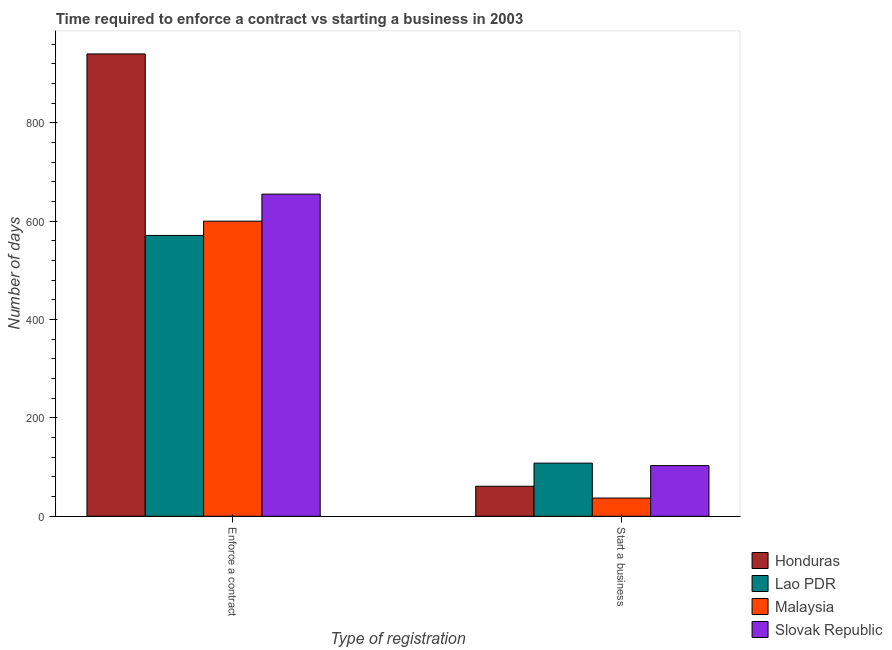How many different coloured bars are there?
Provide a short and direct response. 4. Are the number of bars per tick equal to the number of legend labels?
Keep it short and to the point. Yes. How many bars are there on the 2nd tick from the left?
Make the answer very short. 4. What is the label of the 1st group of bars from the left?
Give a very brief answer. Enforce a contract. What is the number of days to start a business in Honduras?
Give a very brief answer. 61. Across all countries, what is the maximum number of days to enforece a contract?
Your response must be concise. 940. Across all countries, what is the minimum number of days to enforece a contract?
Give a very brief answer. 571. In which country was the number of days to enforece a contract maximum?
Give a very brief answer. Honduras. In which country was the number of days to start a business minimum?
Your answer should be very brief. Malaysia. What is the total number of days to start a business in the graph?
Keep it short and to the point. 309. What is the difference between the number of days to enforece a contract in Honduras and that in Lao PDR?
Your response must be concise. 369. What is the difference between the number of days to start a business in Lao PDR and the number of days to enforece a contract in Honduras?
Offer a very short reply. -832. What is the average number of days to start a business per country?
Give a very brief answer. 77.25. What is the difference between the number of days to start a business and number of days to enforece a contract in Slovak Republic?
Make the answer very short. -552. In how many countries, is the number of days to start a business greater than 240 days?
Your answer should be compact. 0. What is the ratio of the number of days to enforece a contract in Honduras to that in Lao PDR?
Offer a terse response. 1.65. Is the number of days to start a business in Slovak Republic less than that in Malaysia?
Your answer should be compact. No. What does the 4th bar from the left in Enforce a contract represents?
Make the answer very short. Slovak Republic. What does the 2nd bar from the right in Enforce a contract represents?
Provide a succinct answer. Malaysia. What is the difference between two consecutive major ticks on the Y-axis?
Your answer should be very brief. 200. Are the values on the major ticks of Y-axis written in scientific E-notation?
Offer a very short reply. No. Does the graph contain any zero values?
Provide a short and direct response. No. Does the graph contain grids?
Provide a succinct answer. No. Where does the legend appear in the graph?
Ensure brevity in your answer.  Bottom right. How many legend labels are there?
Make the answer very short. 4. How are the legend labels stacked?
Ensure brevity in your answer.  Vertical. What is the title of the graph?
Offer a terse response. Time required to enforce a contract vs starting a business in 2003. What is the label or title of the X-axis?
Keep it short and to the point. Type of registration. What is the label or title of the Y-axis?
Your answer should be very brief. Number of days. What is the Number of days in Honduras in Enforce a contract?
Your answer should be compact. 940. What is the Number of days in Lao PDR in Enforce a contract?
Offer a very short reply. 571. What is the Number of days of Malaysia in Enforce a contract?
Offer a very short reply. 600. What is the Number of days in Slovak Republic in Enforce a contract?
Provide a succinct answer. 655. What is the Number of days of Honduras in Start a business?
Provide a succinct answer. 61. What is the Number of days in Lao PDR in Start a business?
Provide a short and direct response. 108. What is the Number of days of Slovak Republic in Start a business?
Your answer should be very brief. 103. Across all Type of registration, what is the maximum Number of days in Honduras?
Make the answer very short. 940. Across all Type of registration, what is the maximum Number of days of Lao PDR?
Provide a succinct answer. 571. Across all Type of registration, what is the maximum Number of days in Malaysia?
Offer a terse response. 600. Across all Type of registration, what is the maximum Number of days in Slovak Republic?
Provide a succinct answer. 655. Across all Type of registration, what is the minimum Number of days in Lao PDR?
Your response must be concise. 108. Across all Type of registration, what is the minimum Number of days of Malaysia?
Your response must be concise. 37. Across all Type of registration, what is the minimum Number of days in Slovak Republic?
Give a very brief answer. 103. What is the total Number of days in Honduras in the graph?
Keep it short and to the point. 1001. What is the total Number of days in Lao PDR in the graph?
Your answer should be very brief. 679. What is the total Number of days in Malaysia in the graph?
Your response must be concise. 637. What is the total Number of days of Slovak Republic in the graph?
Provide a short and direct response. 758. What is the difference between the Number of days in Honduras in Enforce a contract and that in Start a business?
Ensure brevity in your answer.  879. What is the difference between the Number of days in Lao PDR in Enforce a contract and that in Start a business?
Provide a succinct answer. 463. What is the difference between the Number of days in Malaysia in Enforce a contract and that in Start a business?
Offer a very short reply. 563. What is the difference between the Number of days of Slovak Republic in Enforce a contract and that in Start a business?
Keep it short and to the point. 552. What is the difference between the Number of days in Honduras in Enforce a contract and the Number of days in Lao PDR in Start a business?
Give a very brief answer. 832. What is the difference between the Number of days in Honduras in Enforce a contract and the Number of days in Malaysia in Start a business?
Offer a very short reply. 903. What is the difference between the Number of days of Honduras in Enforce a contract and the Number of days of Slovak Republic in Start a business?
Make the answer very short. 837. What is the difference between the Number of days of Lao PDR in Enforce a contract and the Number of days of Malaysia in Start a business?
Ensure brevity in your answer.  534. What is the difference between the Number of days in Lao PDR in Enforce a contract and the Number of days in Slovak Republic in Start a business?
Keep it short and to the point. 468. What is the difference between the Number of days in Malaysia in Enforce a contract and the Number of days in Slovak Republic in Start a business?
Provide a short and direct response. 497. What is the average Number of days of Honduras per Type of registration?
Provide a succinct answer. 500.5. What is the average Number of days of Lao PDR per Type of registration?
Offer a very short reply. 339.5. What is the average Number of days in Malaysia per Type of registration?
Your answer should be very brief. 318.5. What is the average Number of days in Slovak Republic per Type of registration?
Your response must be concise. 379. What is the difference between the Number of days in Honduras and Number of days in Lao PDR in Enforce a contract?
Give a very brief answer. 369. What is the difference between the Number of days of Honduras and Number of days of Malaysia in Enforce a contract?
Provide a short and direct response. 340. What is the difference between the Number of days in Honduras and Number of days in Slovak Republic in Enforce a contract?
Give a very brief answer. 285. What is the difference between the Number of days of Lao PDR and Number of days of Malaysia in Enforce a contract?
Your answer should be very brief. -29. What is the difference between the Number of days of Lao PDR and Number of days of Slovak Republic in Enforce a contract?
Offer a terse response. -84. What is the difference between the Number of days of Malaysia and Number of days of Slovak Republic in Enforce a contract?
Keep it short and to the point. -55. What is the difference between the Number of days of Honduras and Number of days of Lao PDR in Start a business?
Your answer should be very brief. -47. What is the difference between the Number of days in Honduras and Number of days in Slovak Republic in Start a business?
Give a very brief answer. -42. What is the difference between the Number of days in Lao PDR and Number of days in Malaysia in Start a business?
Offer a terse response. 71. What is the difference between the Number of days in Malaysia and Number of days in Slovak Republic in Start a business?
Ensure brevity in your answer.  -66. What is the ratio of the Number of days in Honduras in Enforce a contract to that in Start a business?
Make the answer very short. 15.41. What is the ratio of the Number of days of Lao PDR in Enforce a contract to that in Start a business?
Ensure brevity in your answer.  5.29. What is the ratio of the Number of days of Malaysia in Enforce a contract to that in Start a business?
Make the answer very short. 16.22. What is the ratio of the Number of days in Slovak Republic in Enforce a contract to that in Start a business?
Keep it short and to the point. 6.36. What is the difference between the highest and the second highest Number of days of Honduras?
Your answer should be very brief. 879. What is the difference between the highest and the second highest Number of days of Lao PDR?
Offer a very short reply. 463. What is the difference between the highest and the second highest Number of days of Malaysia?
Give a very brief answer. 563. What is the difference between the highest and the second highest Number of days of Slovak Republic?
Keep it short and to the point. 552. What is the difference between the highest and the lowest Number of days in Honduras?
Your answer should be compact. 879. What is the difference between the highest and the lowest Number of days of Lao PDR?
Ensure brevity in your answer.  463. What is the difference between the highest and the lowest Number of days of Malaysia?
Make the answer very short. 563. What is the difference between the highest and the lowest Number of days of Slovak Republic?
Offer a very short reply. 552. 